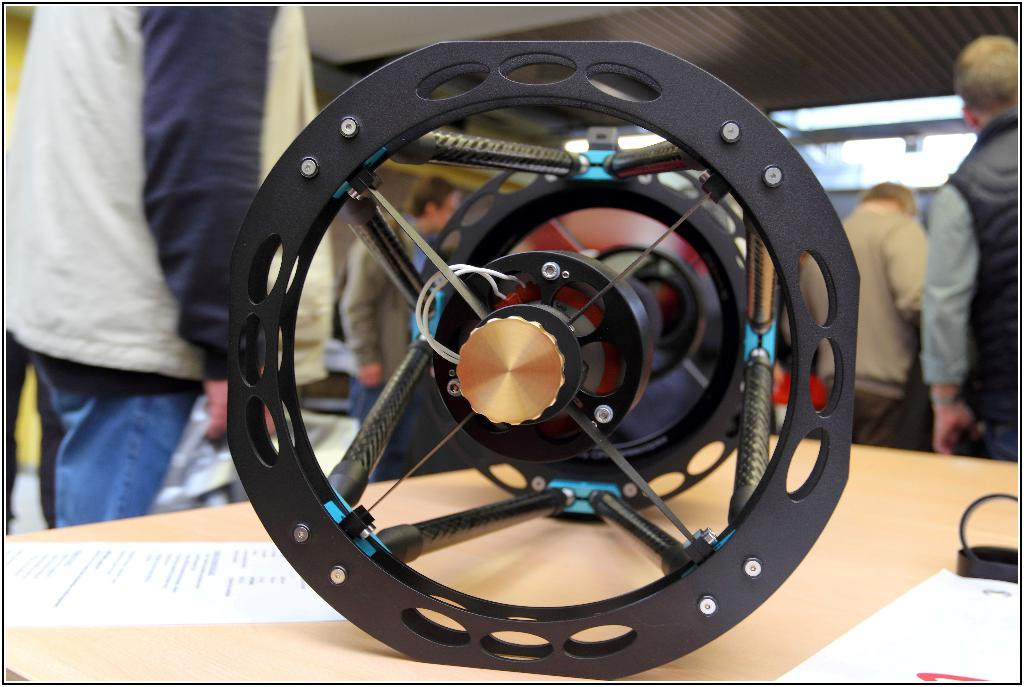What object is placed on the table in the image? There is a wheel on the table. What else can be seen on the table? There is a paper on the table. Can you describe the people in the image? People are standing at the back. What type of relation is depicted between the wheel and the paper in the image? There is no relation depicted between the wheel and the paper in the image; they are simply two separate objects on the table. 